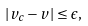Convert formula to latex. <formula><loc_0><loc_0><loc_500><loc_500>| { v _ { c } } - { v } | \leq \epsilon ,</formula> 